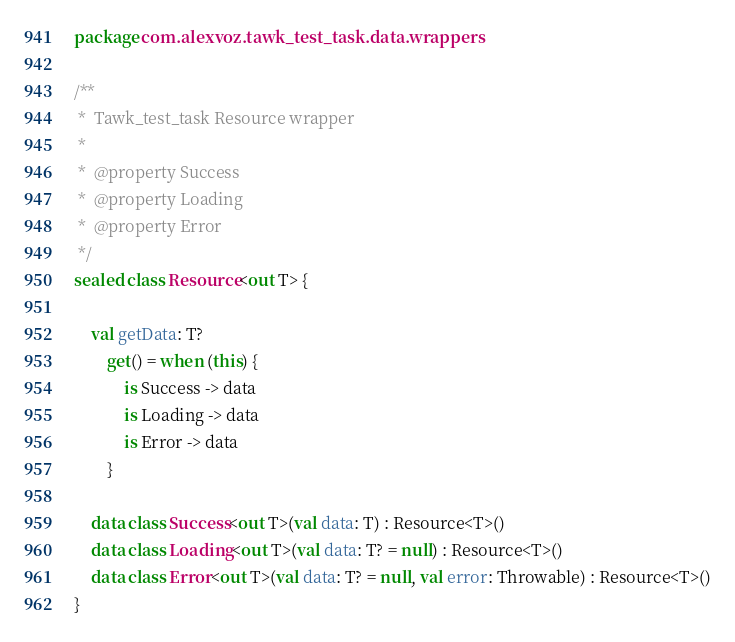<code> <loc_0><loc_0><loc_500><loc_500><_Kotlin_>package com.alexvoz.tawk_test_task.data.wrappers

/**
 *  Tawk_test_task Resource wrapper
 *
 *  @property Success
 *  @property Loading
 *  @property Error
 */
sealed class Resource<out T> {

    val getData: T?
        get() = when (this) {
            is Success -> data
            is Loading -> data
            is Error -> data
        }

    data class Success<out T>(val data: T) : Resource<T>()
    data class Loading<out T>(val data: T? = null) : Resource<T>()
    data class Error<out T>(val data: T? = null, val error: Throwable) : Resource<T>()
}




</code> 